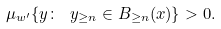<formula> <loc_0><loc_0><loc_500><loc_500>\mu _ { w ^ { \prime } } \{ y \colon \ y _ { \geq n } \in B _ { \geq n } ( x ) \} > 0 .</formula> 